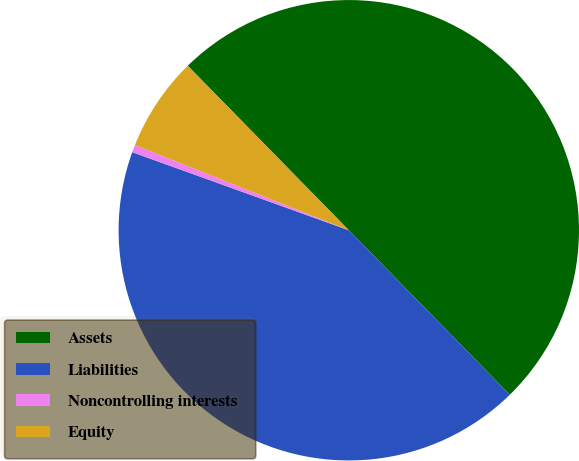Convert chart. <chart><loc_0><loc_0><loc_500><loc_500><pie_chart><fcel>Assets<fcel>Liabilities<fcel>Noncontrolling interests<fcel>Equity<nl><fcel>50.0%<fcel>42.84%<fcel>0.53%<fcel>6.63%<nl></chart> 